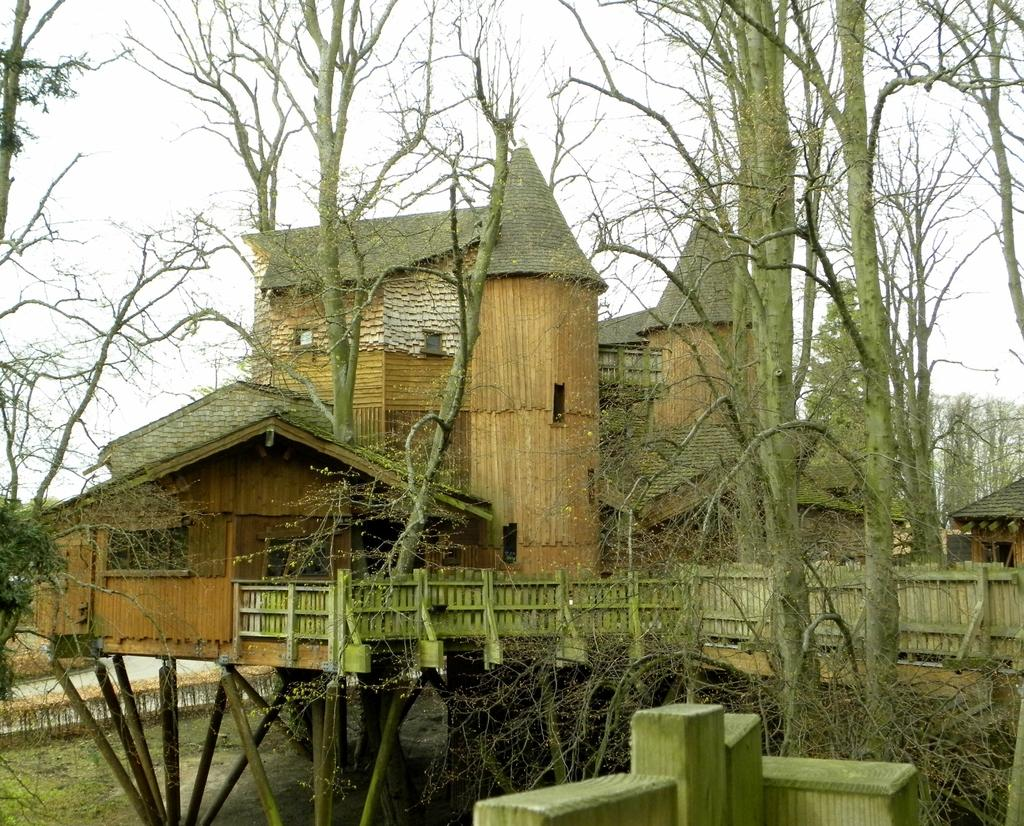What type of house is in the image? There is an old house in the image. What material is used for the fencing around the house? The house has wooden fencing. What can be seen around the house in the image? There are trees around the house. What type of fruit is hanging from the trees around the house in the image? There is no fruit visible in the image; only trees are present around the house. 